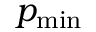Convert formula to latex. <formula><loc_0><loc_0><loc_500><loc_500>p _ { \min }</formula> 